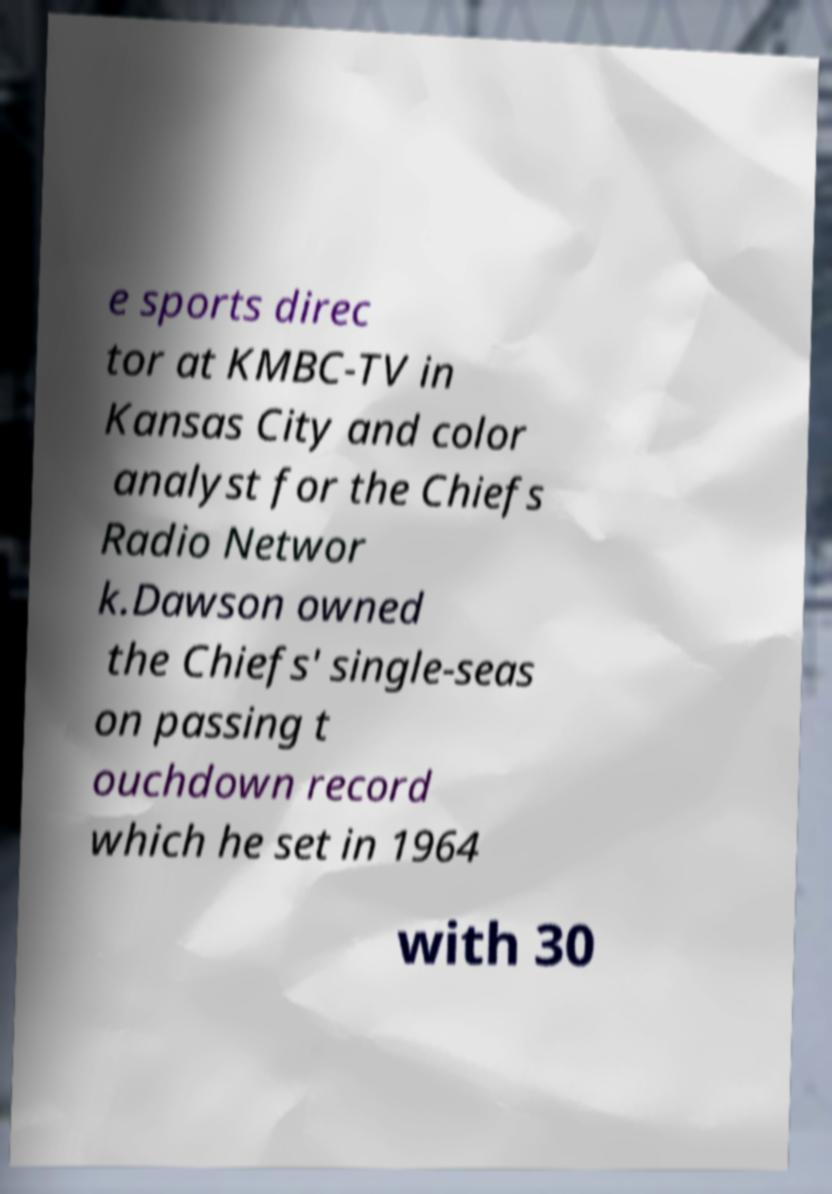Could you assist in decoding the text presented in this image and type it out clearly? e sports direc tor at KMBC-TV in Kansas City and color analyst for the Chiefs Radio Networ k.Dawson owned the Chiefs' single-seas on passing t ouchdown record which he set in 1964 with 30 